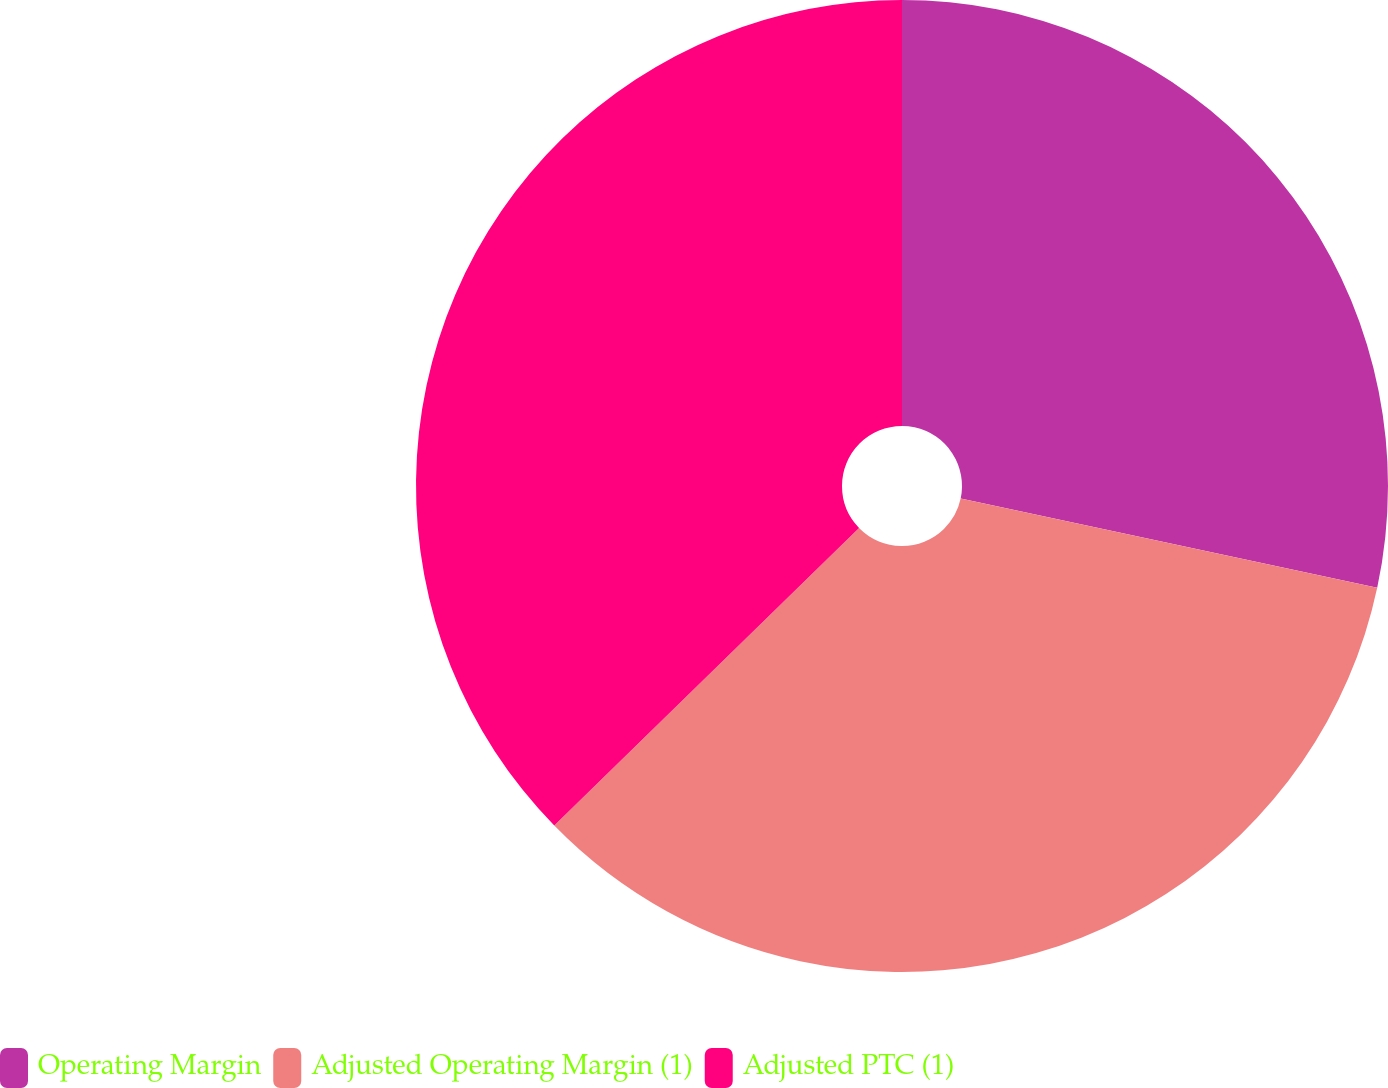Convert chart. <chart><loc_0><loc_0><loc_500><loc_500><pie_chart><fcel>Operating Margin<fcel>Adjusted Operating Margin (1)<fcel>Adjusted PTC (1)<nl><fcel>28.36%<fcel>34.33%<fcel>37.31%<nl></chart> 